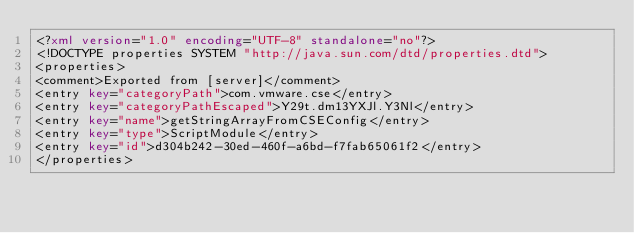Convert code to text. <code><loc_0><loc_0><loc_500><loc_500><_XML_><?xml version="1.0" encoding="UTF-8" standalone="no"?>
<!DOCTYPE properties SYSTEM "http://java.sun.com/dtd/properties.dtd">
<properties>
<comment>Exported from [server]</comment>
<entry key="categoryPath">com.vmware.cse</entry>
<entry key="categoryPathEscaped">Y29t.dm13YXJl.Y3Nl</entry>
<entry key="name">getStringArrayFromCSEConfig</entry>
<entry key="type">ScriptModule</entry>
<entry key="id">d304b242-30ed-460f-a6bd-f7fab65061f2</entry>
</properties>
</code> 